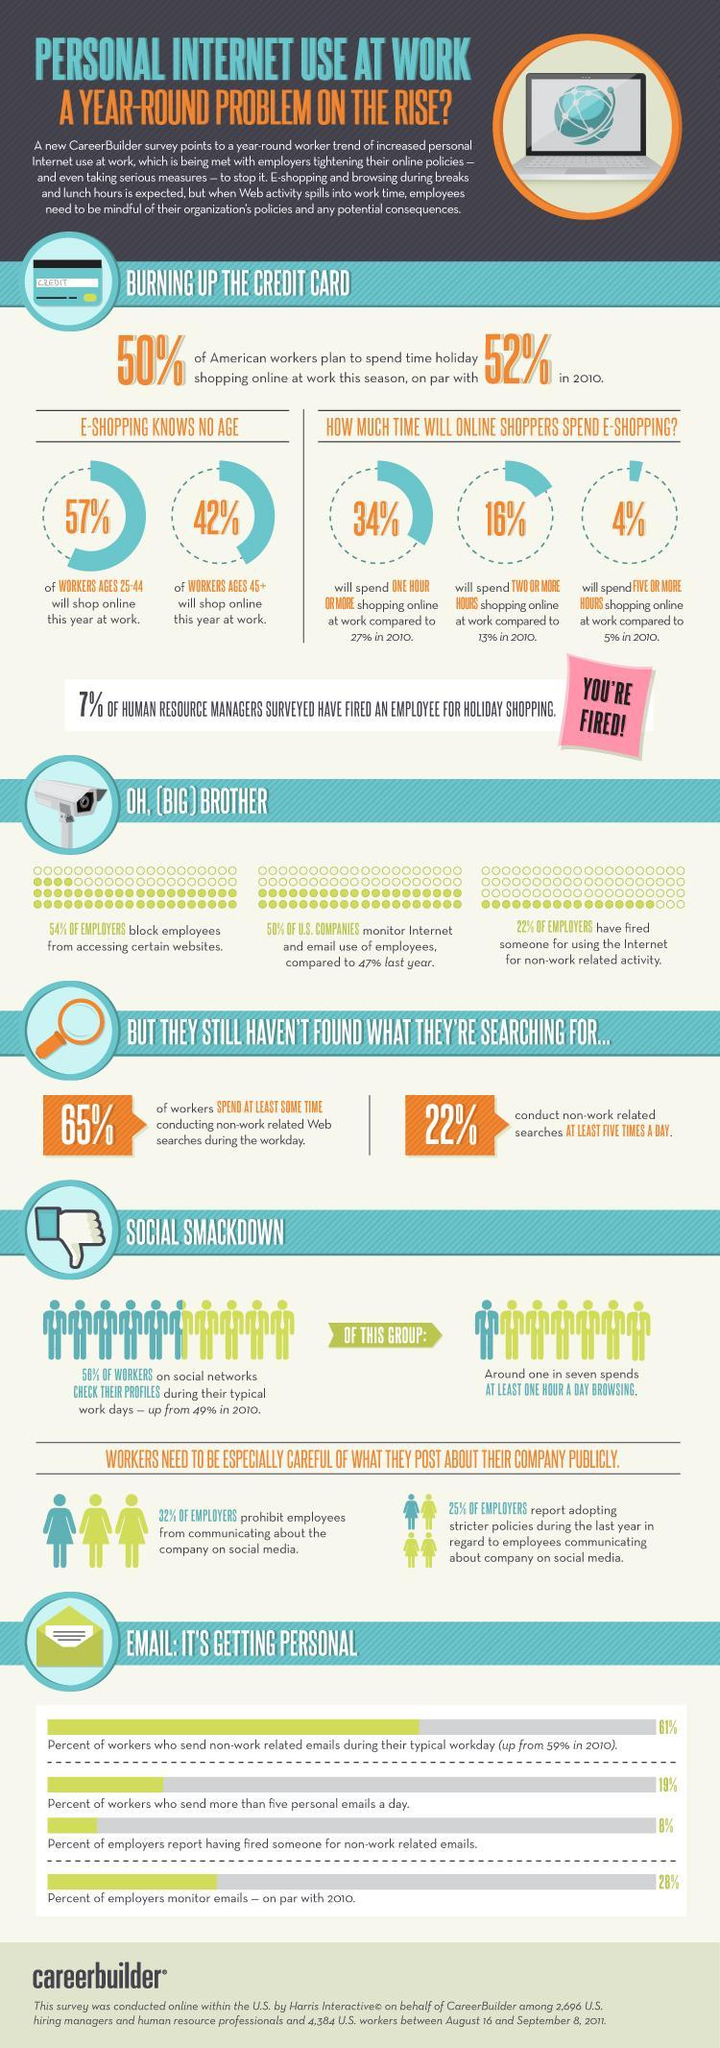What percentage of employers allow employees to communicate about the company on social media?
Answer the question with a short phrase. 68% What percentage of employers allow employees to access certain websites? 46% 